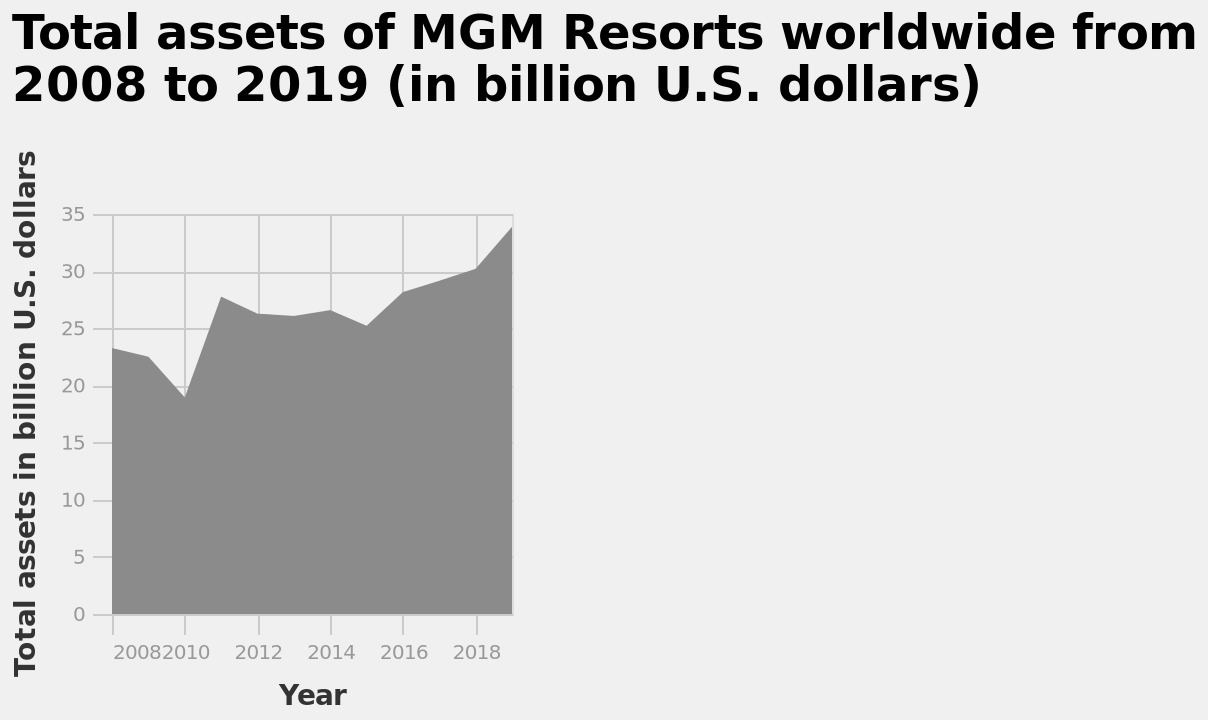<image>
What is the range of total assets shown on the y-axis? The y-axis shows the range of total assets from 0 to 35 billion U.S. dollars. What was the highest value of assets reached by MGM studios?  The highest value of assets reached by MGM studios was 34 billion US dollars. How many dips in assets did MGM studios experience during the 11-year period? MGM studios experienced two dips in assets during the 11-year period. What is the name of the area chart?  The area chart is called "Total assets of MGM Resorts worldwide from 2008 to 2019 (in billion U.S. dollars)." Did MGM studios recover all the assets lost during the dips?  Yes, MGM studios recovered all the assets lost during the dips, both in 2008-2010 and 2014-2015. When did the first dip in assets occur for MGM studios?  The first dip in assets for MGM studios occurred in 2008-2010. please describe the details of the chart This area chart is called Total assets of MGM Resorts worldwide from 2008 to 2019 (in billion U.S. dollars). A linear scale with a minimum of 2008 and a maximum of 2018 can be seen on the x-axis, marked Year. A linear scale from 0 to 35 can be seen along the y-axis, marked Total assets in billion U.S. dollars. Is the line chart known as "Total liabilities of MGM Resorts worldwide from 2008 to 2019 (in billion U.S. dollars)"? No. The area chart is called "Total assets of MGM Resorts worldwide from 2008 to 2019 (in billion U.S. dollars)." Did the first peak in assets for MGM studios occur in 2008-2010? No. The first dip in assets for MGM studios occurred in 2008-2010. 